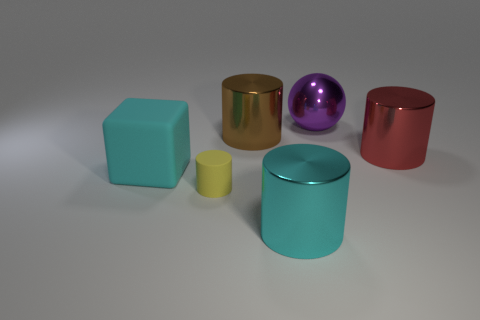Add 1 purple objects. How many objects exist? 7 Subtract all balls. How many objects are left? 5 Add 5 tiny yellow objects. How many tiny yellow objects are left? 6 Add 6 tiny cylinders. How many tiny cylinders exist? 7 Subtract 0 yellow balls. How many objects are left? 6 Subtract all tiny gray balls. Subtract all cyan rubber cubes. How many objects are left? 5 